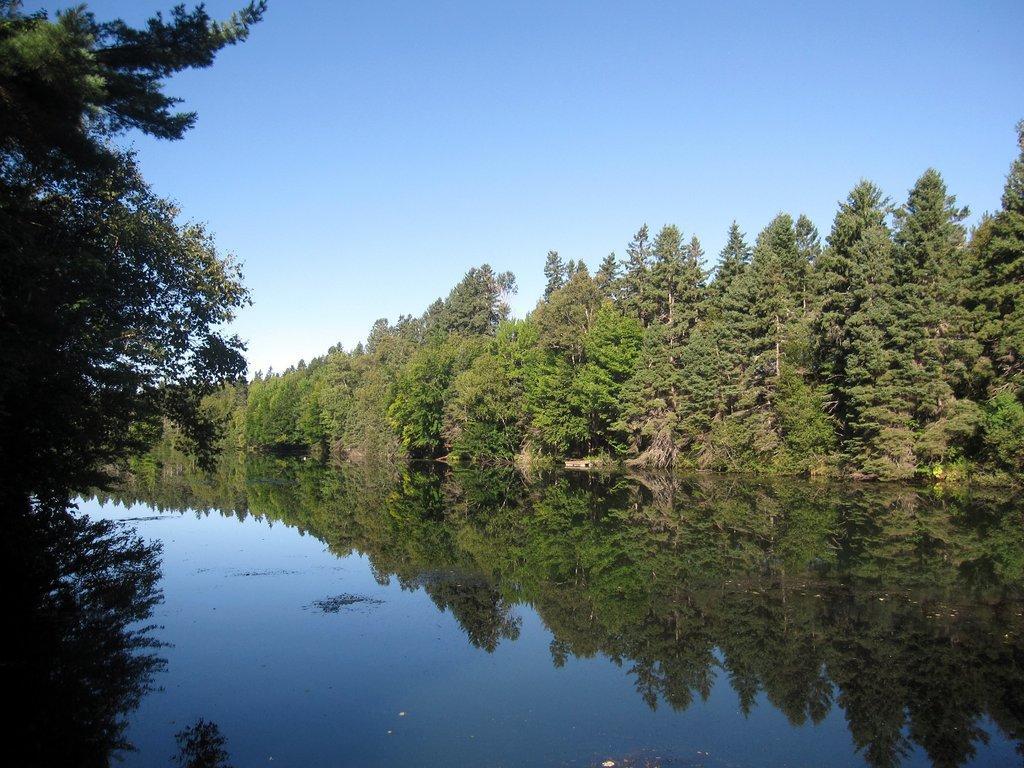Describe this image in one or two sentences. In the image we can see water, trees and the sky. In the water we can see the reflection of the trees and the sky. 